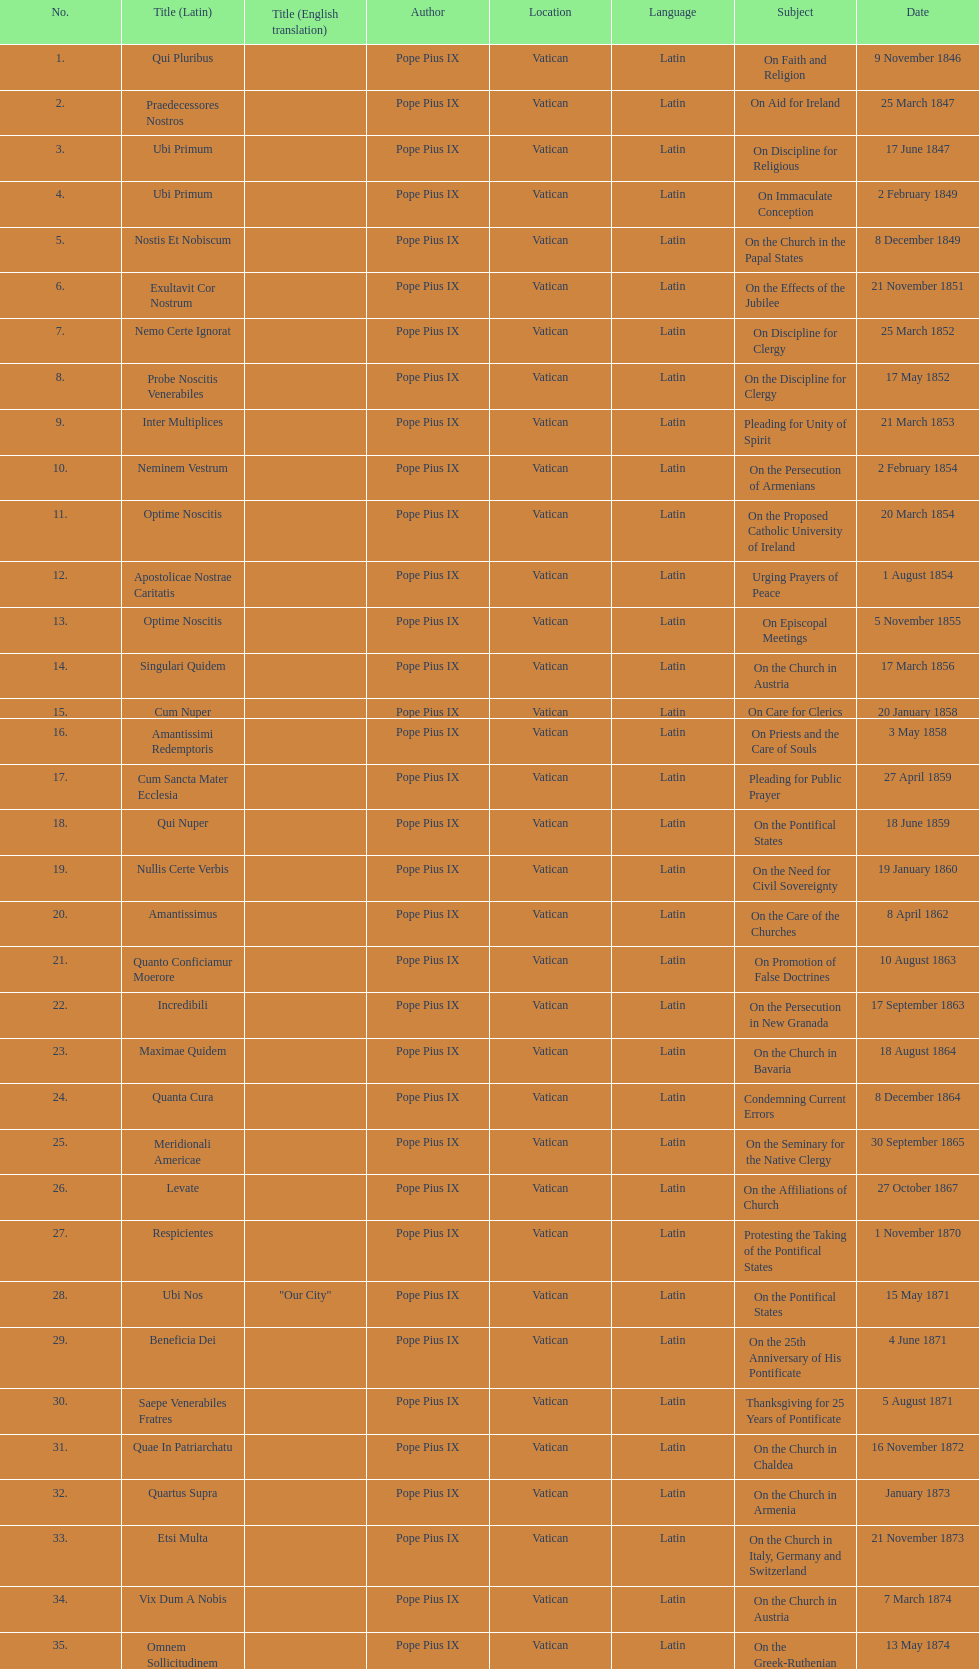How many encyclicals were issued between august 15, 1854 and october 26, 1867? 13. 